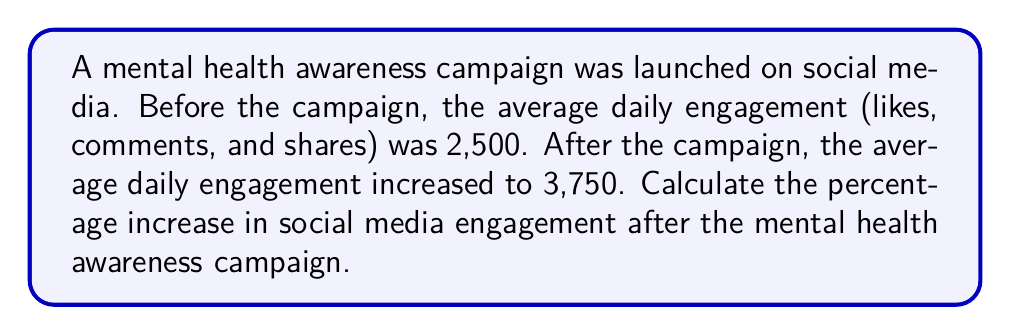Solve this math problem. To calculate the percentage increase in social media engagement, we need to follow these steps:

1. Calculate the absolute increase in engagement:
   $\text{Increase} = \text{New Value} - \text{Original Value}$
   $\text{Increase} = 3,750 - 2,500 = 1,250$

2. Calculate the percentage increase using the formula:
   $\text{Percentage Increase} = \frac{\text{Increase}}{\text{Original Value}} \times 100\%$

3. Substitute the values into the formula:
   $$\text{Percentage Increase} = \frac{1,250}{2,500} \times 100\%$$

4. Simplify the fraction:
   $$\text{Percentage Increase} = \frac{1,250}{2,500} \times 100\% = 0.5 \times 100\% = 50\%$$

Therefore, the percentage increase in social media engagement after the mental health awareness campaign is 50%.
Answer: 50% 